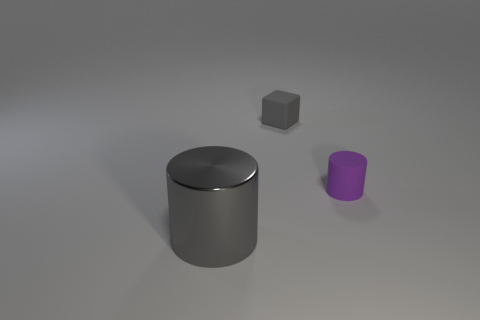Add 1 small purple cylinders. How many objects exist? 4 Subtract all cylinders. How many objects are left? 1 Subtract all small metal spheres. Subtract all big gray metallic objects. How many objects are left? 2 Add 1 cubes. How many cubes are left? 2 Add 1 purple matte balls. How many purple matte balls exist? 1 Subtract 0 cyan blocks. How many objects are left? 3 